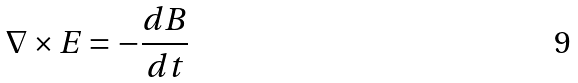<formula> <loc_0><loc_0><loc_500><loc_500>\nabla \times E = - \frac { d B } { d t }</formula> 